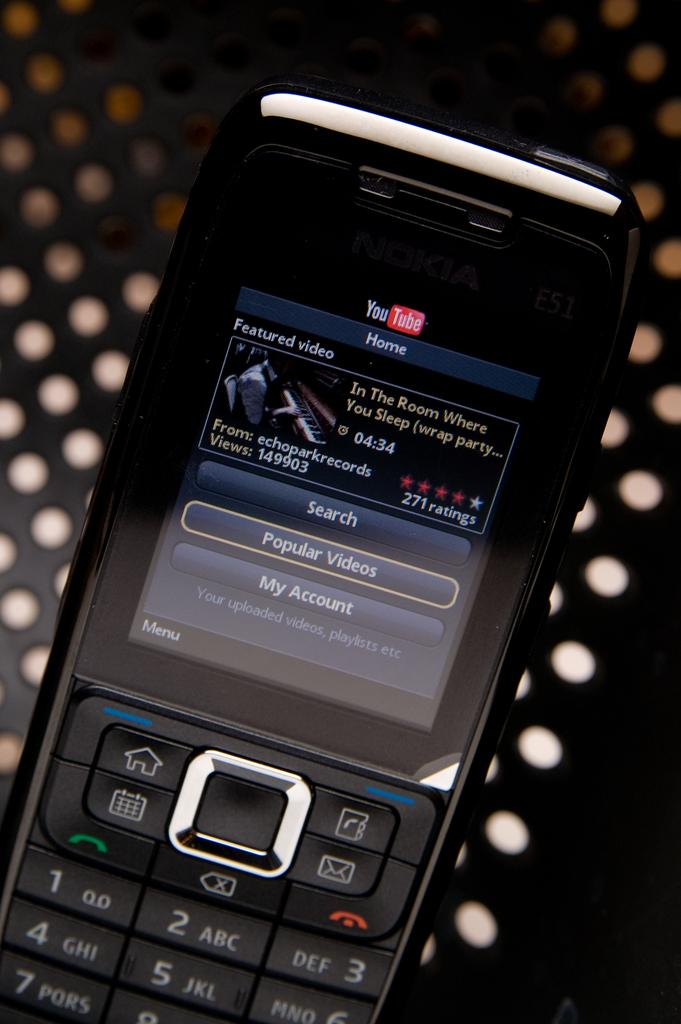<image>
Offer a succinct explanation of the picture presented. A cell phone on which the words Featured Video can be seen. 